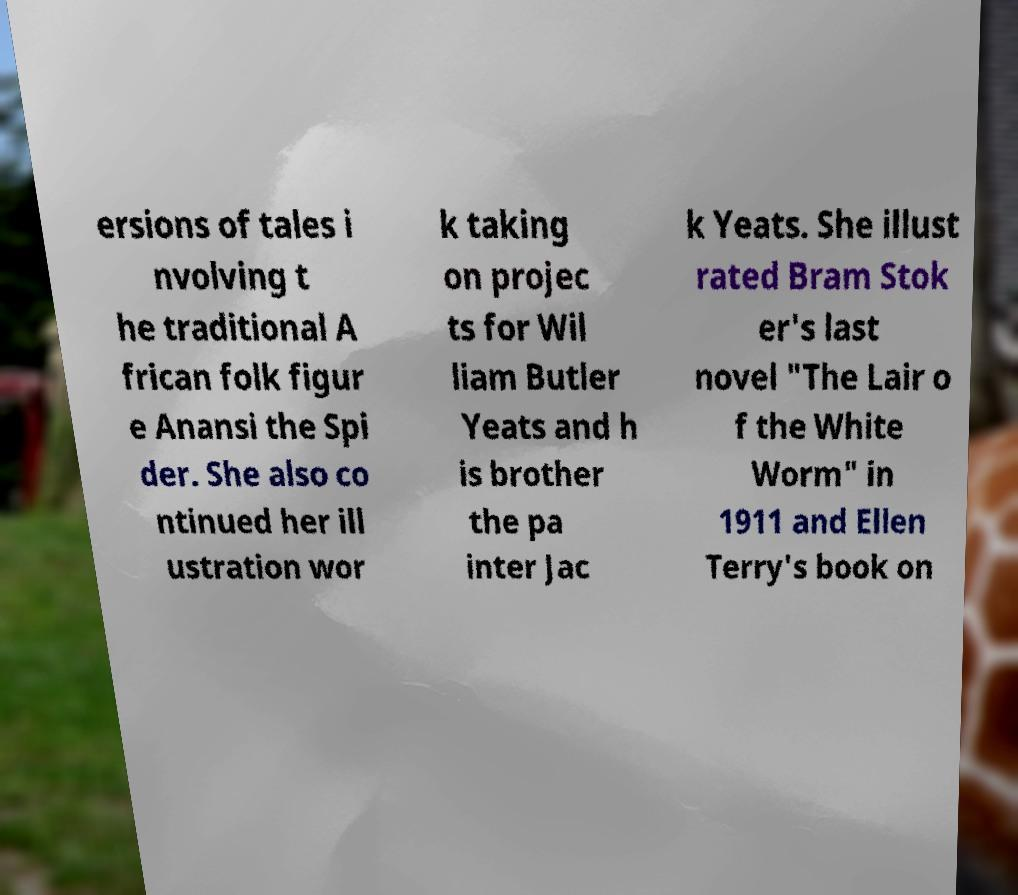Could you extract and type out the text from this image? ersions of tales i nvolving t he traditional A frican folk figur e Anansi the Spi der. She also co ntinued her ill ustration wor k taking on projec ts for Wil liam Butler Yeats and h is brother the pa inter Jac k Yeats. She illust rated Bram Stok er's last novel "The Lair o f the White Worm" in 1911 and Ellen Terry's book on 